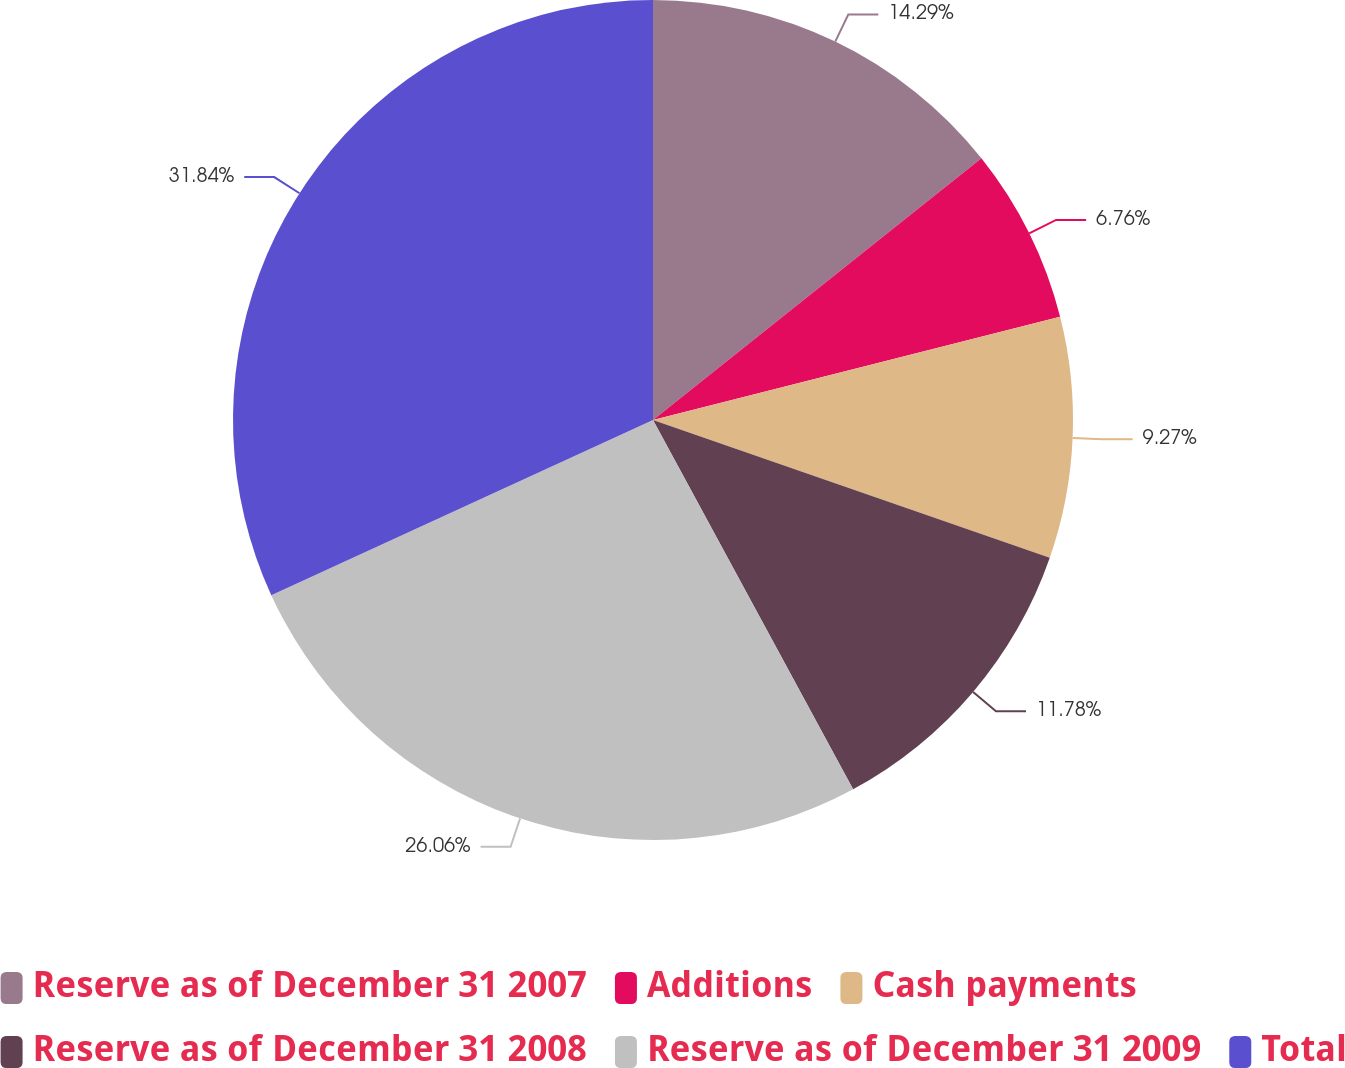Convert chart. <chart><loc_0><loc_0><loc_500><loc_500><pie_chart><fcel>Reserve as of December 31 2007<fcel>Additions<fcel>Cash payments<fcel>Reserve as of December 31 2008<fcel>Reserve as of December 31 2009<fcel>Total<nl><fcel>14.29%<fcel>6.76%<fcel>9.27%<fcel>11.78%<fcel>26.06%<fcel>31.85%<nl></chart> 